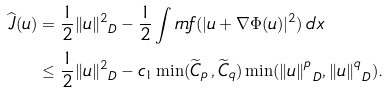<formula> <loc_0><loc_0><loc_500><loc_500>\widehat { J } ( u ) & = \frac { 1 } { 2 } \| u \| _ { \ D } ^ { 2 } - \frac { 1 } { 2 } \int r n f ( | u + \nabla \Phi ( u ) | ^ { 2 } ) \, d x \\ & \leq \frac { 1 } { 2 } \| u \| _ { \ D } ^ { 2 } - c _ { 1 } \min ( \widetilde { C } _ { p } \, , \widetilde { C } _ { q } ) \min ( \| u \| _ { \ D } ^ { p } , \| u \| _ { \ D } ^ { q } ) .</formula> 